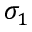Convert formula to latex. <formula><loc_0><loc_0><loc_500><loc_500>\sigma _ { 1 }</formula> 